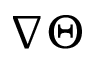<formula> <loc_0><loc_0><loc_500><loc_500>\nabla \Theta</formula> 